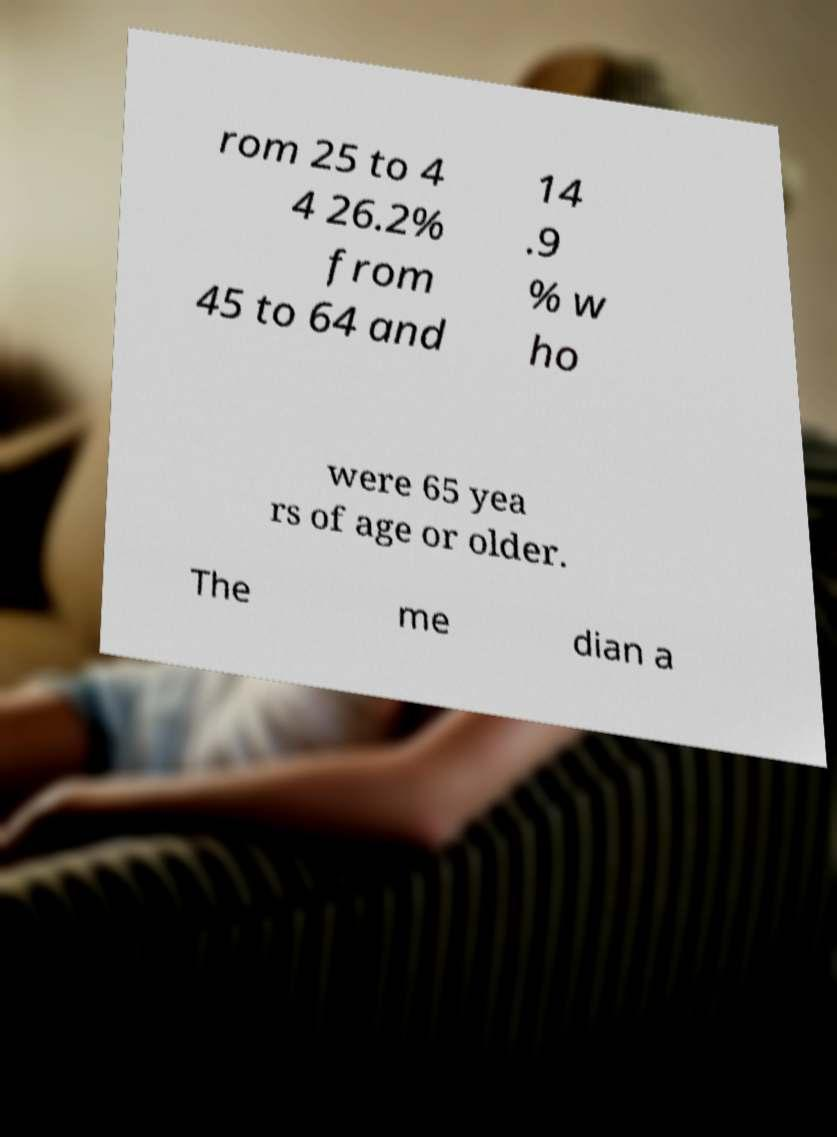There's text embedded in this image that I need extracted. Can you transcribe it verbatim? rom 25 to 4 4 26.2% from 45 to 64 and 14 .9 % w ho were 65 yea rs of age or older. The me dian a 